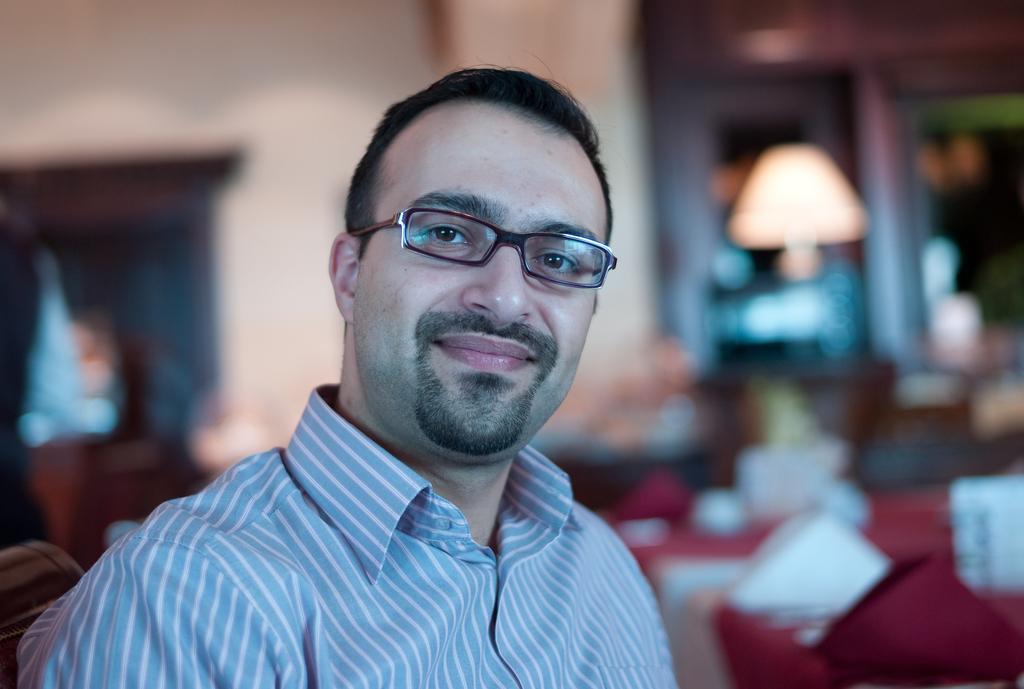Please provide a concise description of this image. There is a person in a shirt, wearing a spectacle and smiling. And the background is blurred. 